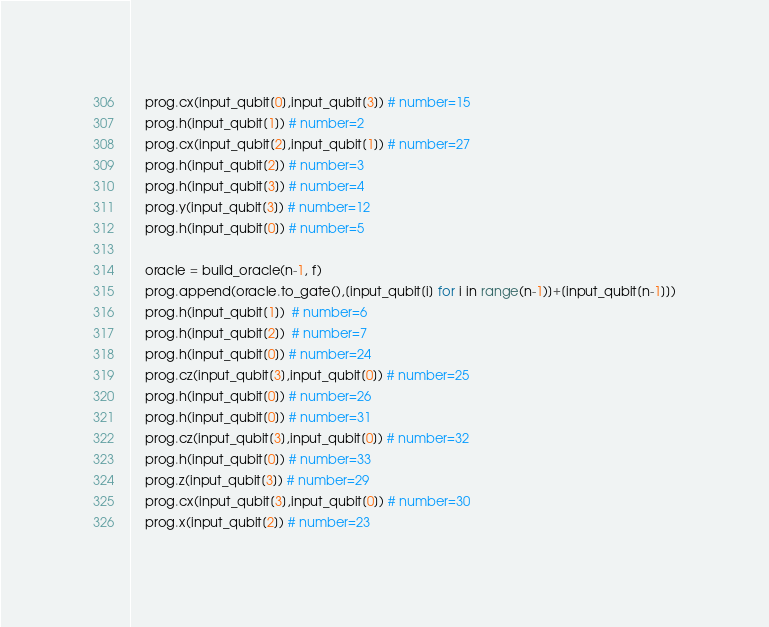Convert code to text. <code><loc_0><loc_0><loc_500><loc_500><_Python_>    prog.cx(input_qubit[0],input_qubit[3]) # number=15
    prog.h(input_qubit[1]) # number=2
    prog.cx(input_qubit[2],input_qubit[1]) # number=27
    prog.h(input_qubit[2]) # number=3
    prog.h(input_qubit[3]) # number=4
    prog.y(input_qubit[3]) # number=12
    prog.h(input_qubit[0]) # number=5

    oracle = build_oracle(n-1, f)
    prog.append(oracle.to_gate(),[input_qubit[i] for i in range(n-1)]+[input_qubit[n-1]])
    prog.h(input_qubit[1])  # number=6
    prog.h(input_qubit[2])  # number=7
    prog.h(input_qubit[0]) # number=24
    prog.cz(input_qubit[3],input_qubit[0]) # number=25
    prog.h(input_qubit[0]) # number=26
    prog.h(input_qubit[0]) # number=31
    prog.cz(input_qubit[3],input_qubit[0]) # number=32
    prog.h(input_qubit[0]) # number=33
    prog.z(input_qubit[3]) # number=29
    prog.cx(input_qubit[3],input_qubit[0]) # number=30
    prog.x(input_qubit[2]) # number=23</code> 